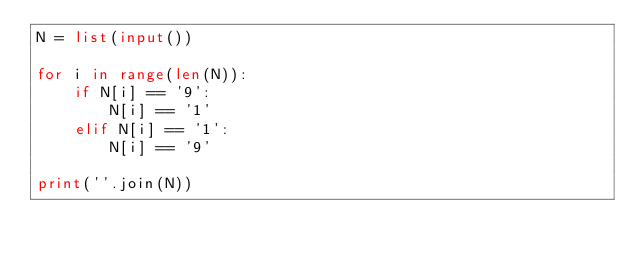Convert code to text. <code><loc_0><loc_0><loc_500><loc_500><_Python_>N = list(input())

for i in range(len(N)):
    if N[i] == '9':
        N[i] == '1'
    elif N[i] == '1':
        N[i] == '9'

print(''.join(N))</code> 